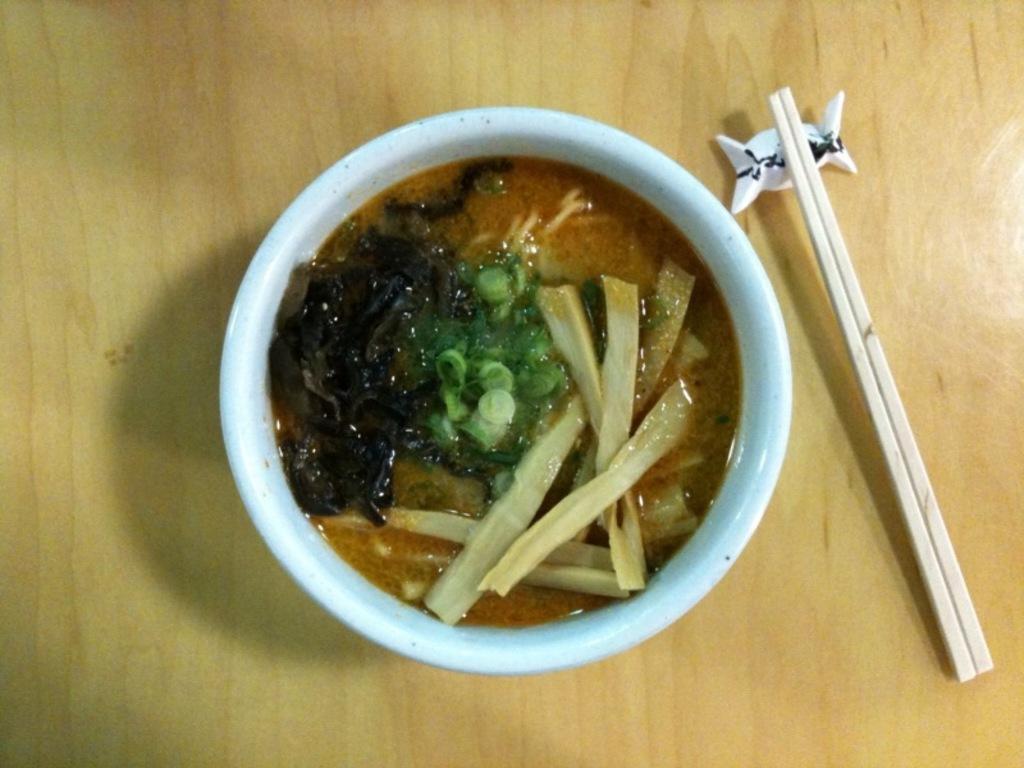Can you describe this image briefly? In this picture we can see a bowl with food item in it and aside to this bowl we have two sticks and a chocolate symbol and this are placed on a wooden table. 